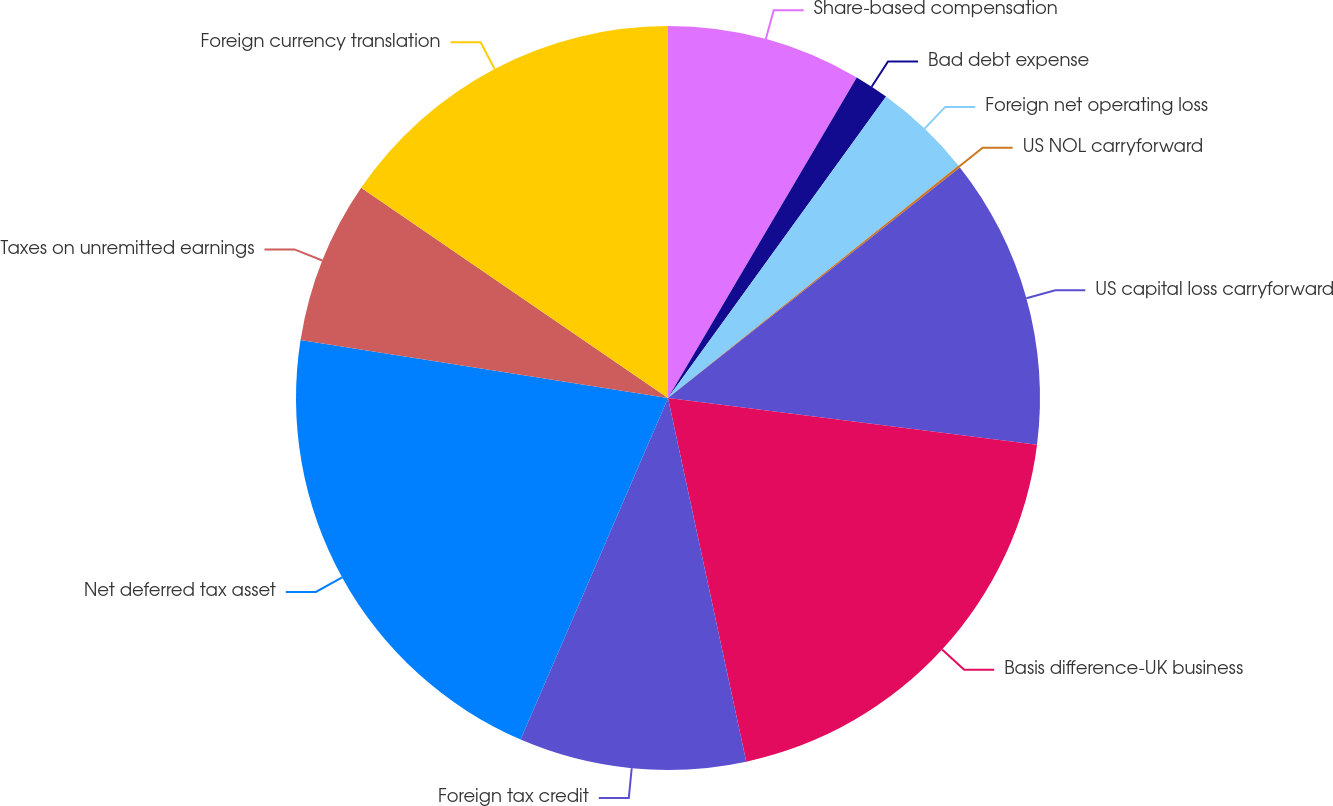Convert chart. <chart><loc_0><loc_0><loc_500><loc_500><pie_chart><fcel>Share-based compensation<fcel>Bad debt expense<fcel>Foreign net operating loss<fcel>US NOL carryforward<fcel>US capital loss carryforward<fcel>Basis difference-UK business<fcel>Foreign tax credit<fcel>Net deferred tax asset<fcel>Taxes on unremitted earnings<fcel>Foreign currency translation<nl><fcel>8.47%<fcel>1.5%<fcel>4.29%<fcel>0.1%<fcel>12.65%<fcel>19.62%<fcel>9.86%<fcel>21.01%<fcel>7.07%<fcel>15.44%<nl></chart> 